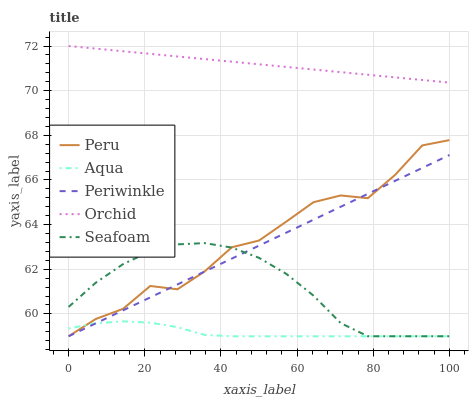Does Aqua have the minimum area under the curve?
Answer yes or no. Yes. Does Orchid have the maximum area under the curve?
Answer yes or no. Yes. Does Seafoam have the minimum area under the curve?
Answer yes or no. No. Does Seafoam have the maximum area under the curve?
Answer yes or no. No. Is Periwinkle the smoothest?
Answer yes or no. Yes. Is Peru the roughest?
Answer yes or no. Yes. Is Aqua the smoothest?
Answer yes or no. No. Is Aqua the roughest?
Answer yes or no. No. Does Periwinkle have the lowest value?
Answer yes or no. Yes. Does Orchid have the lowest value?
Answer yes or no. No. Does Orchid have the highest value?
Answer yes or no. Yes. Does Seafoam have the highest value?
Answer yes or no. No. Is Aqua less than Orchid?
Answer yes or no. Yes. Is Orchid greater than Seafoam?
Answer yes or no. Yes. Does Seafoam intersect Peru?
Answer yes or no. Yes. Is Seafoam less than Peru?
Answer yes or no. No. Is Seafoam greater than Peru?
Answer yes or no. No. Does Aqua intersect Orchid?
Answer yes or no. No. 